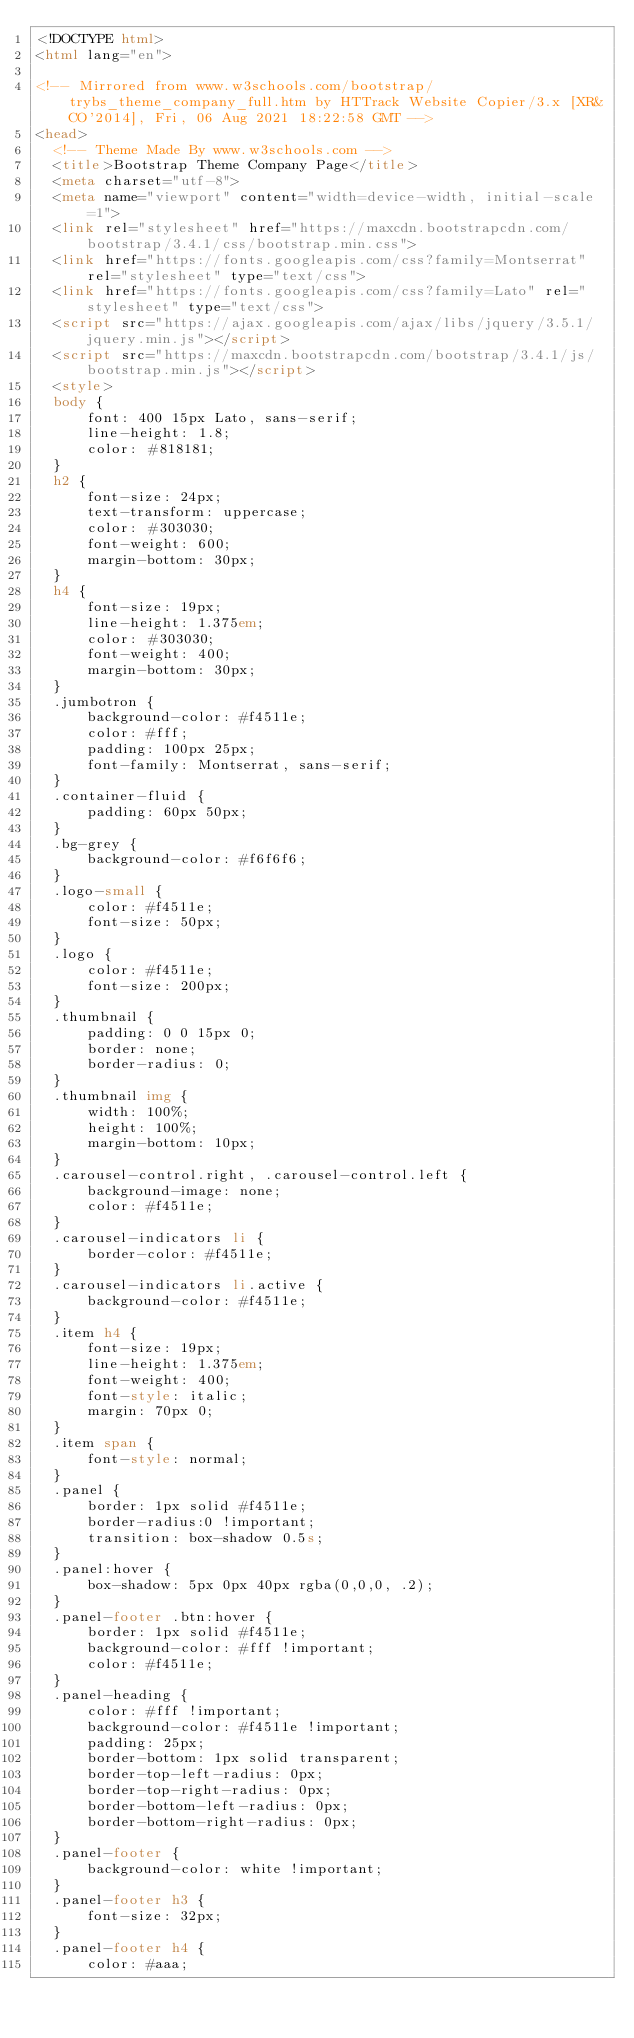<code> <loc_0><loc_0><loc_500><loc_500><_HTML_><!DOCTYPE html>
<html lang="en">

<!-- Mirrored from www.w3schools.com/bootstrap/trybs_theme_company_full.htm by HTTrack Website Copier/3.x [XR&CO'2014], Fri, 06 Aug 2021 18:22:58 GMT -->
<head>
  <!-- Theme Made By www.w3schools.com -->
  <title>Bootstrap Theme Company Page</title>
  <meta charset="utf-8">
  <meta name="viewport" content="width=device-width, initial-scale=1">
  <link rel="stylesheet" href="https://maxcdn.bootstrapcdn.com/bootstrap/3.4.1/css/bootstrap.min.css">
  <link href="https://fonts.googleapis.com/css?family=Montserrat" rel="stylesheet" type="text/css">
  <link href="https://fonts.googleapis.com/css?family=Lato" rel="stylesheet" type="text/css">
  <script src="https://ajax.googleapis.com/ajax/libs/jquery/3.5.1/jquery.min.js"></script>
  <script src="https://maxcdn.bootstrapcdn.com/bootstrap/3.4.1/js/bootstrap.min.js"></script>
  <style>
  body {
      font: 400 15px Lato, sans-serif;
      line-height: 1.8;
      color: #818181;
  }
  h2 {
      font-size: 24px;
      text-transform: uppercase;
      color: #303030;
      font-weight: 600;
      margin-bottom: 30px;
  }
  h4 {
      font-size: 19px;
      line-height: 1.375em;
      color: #303030;
      font-weight: 400;
      margin-bottom: 30px;
  }  
  .jumbotron {
      background-color: #f4511e;
      color: #fff;
      padding: 100px 25px;
      font-family: Montserrat, sans-serif;
  }
  .container-fluid {
      padding: 60px 50px;
  }
  .bg-grey {
      background-color: #f6f6f6;
  }
  .logo-small {
      color: #f4511e;
      font-size: 50px;
  }
  .logo {
      color: #f4511e;
      font-size: 200px;
  }
  .thumbnail {
      padding: 0 0 15px 0;
      border: none;
      border-radius: 0;
  }
  .thumbnail img {
      width: 100%;
      height: 100%;
      margin-bottom: 10px;
  }
  .carousel-control.right, .carousel-control.left {
      background-image: none;
      color: #f4511e;
  }
  .carousel-indicators li {
      border-color: #f4511e;
  }
  .carousel-indicators li.active {
      background-color: #f4511e;
  }
  .item h4 {
      font-size: 19px;
      line-height: 1.375em;
      font-weight: 400;
      font-style: italic;
      margin: 70px 0;
  }
  .item span {
      font-style: normal;
  }
  .panel {
      border: 1px solid #f4511e; 
      border-radius:0 !important;
      transition: box-shadow 0.5s;
  }
  .panel:hover {
      box-shadow: 5px 0px 40px rgba(0,0,0, .2);
  }
  .panel-footer .btn:hover {
      border: 1px solid #f4511e;
      background-color: #fff !important;
      color: #f4511e;
  }
  .panel-heading {
      color: #fff !important;
      background-color: #f4511e !important;
      padding: 25px;
      border-bottom: 1px solid transparent;
      border-top-left-radius: 0px;
      border-top-right-radius: 0px;
      border-bottom-left-radius: 0px;
      border-bottom-right-radius: 0px;
  }
  .panel-footer {
      background-color: white !important;
  }
  .panel-footer h3 {
      font-size: 32px;
  }
  .panel-footer h4 {
      color: #aaa;</code> 